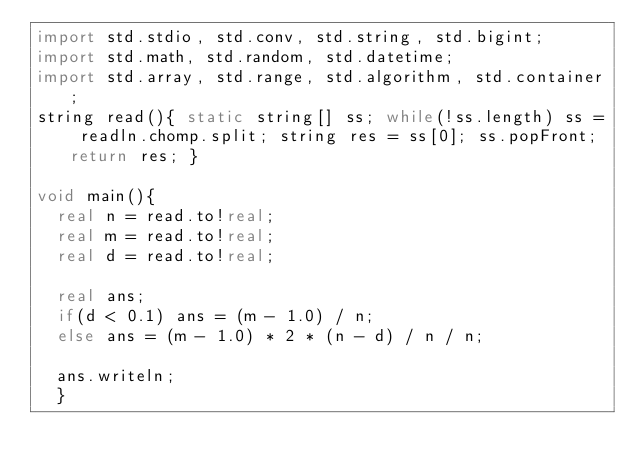Convert code to text. <code><loc_0><loc_0><loc_500><loc_500><_D_>import std.stdio, std.conv, std.string, std.bigint;
import std.math, std.random, std.datetime;
import std.array, std.range, std.algorithm, std.container;
string read(){ static string[] ss; while(!ss.length) ss = readln.chomp.split; string res = ss[0]; ss.popFront; return res; }

void main(){
	real n = read.to!real;
	real m = read.to!real;
	real d = read.to!real;
	
	real ans;
	if(d < 0.1) ans = (m - 1.0) / n;
	else ans = (m - 1.0) * 2 * (n - d) / n / n;
	
	ans.writeln;
	}
	
	</code> 